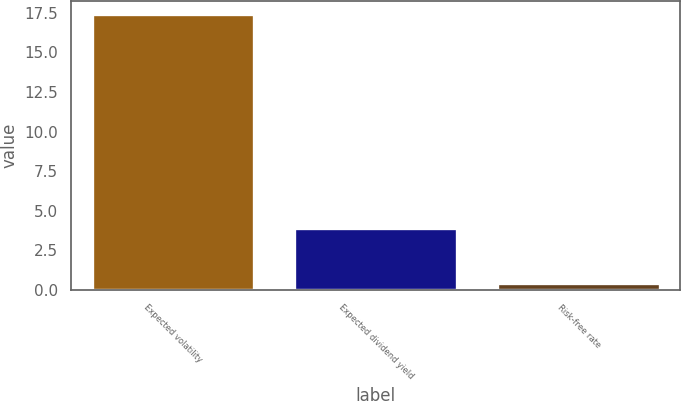Convert chart. <chart><loc_0><loc_0><loc_500><loc_500><bar_chart><fcel>Expected volatility<fcel>Expected dividend yield<fcel>Risk-free rate<nl><fcel>17.4<fcel>3.9<fcel>0.4<nl></chart> 